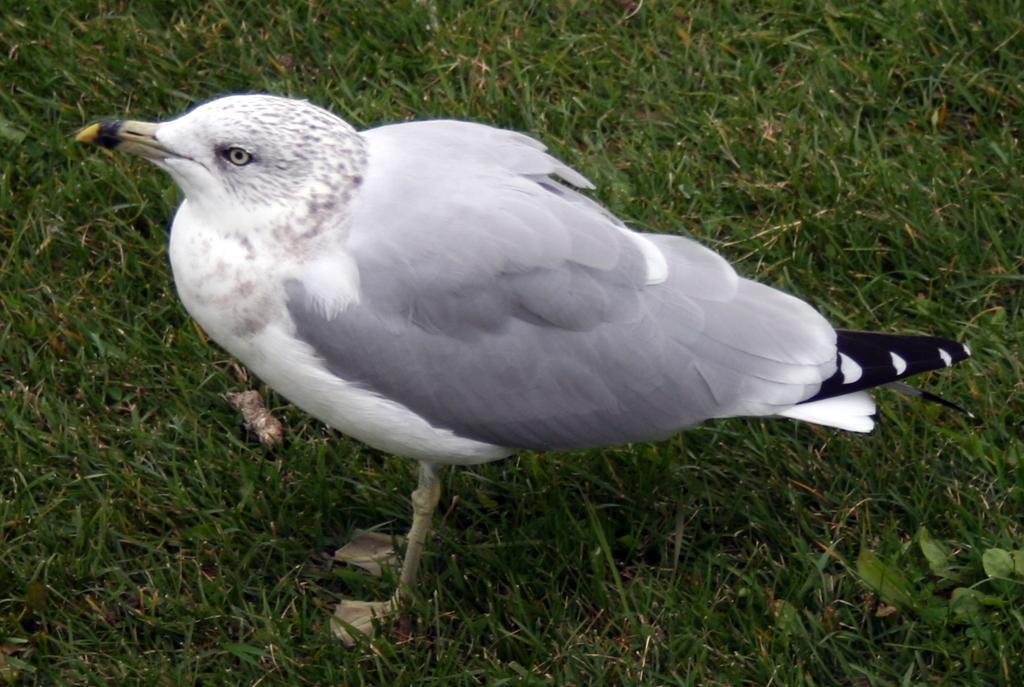Could you give a brief overview of what you see in this image? In this picture I can see there is a bird here and it is in white color. 